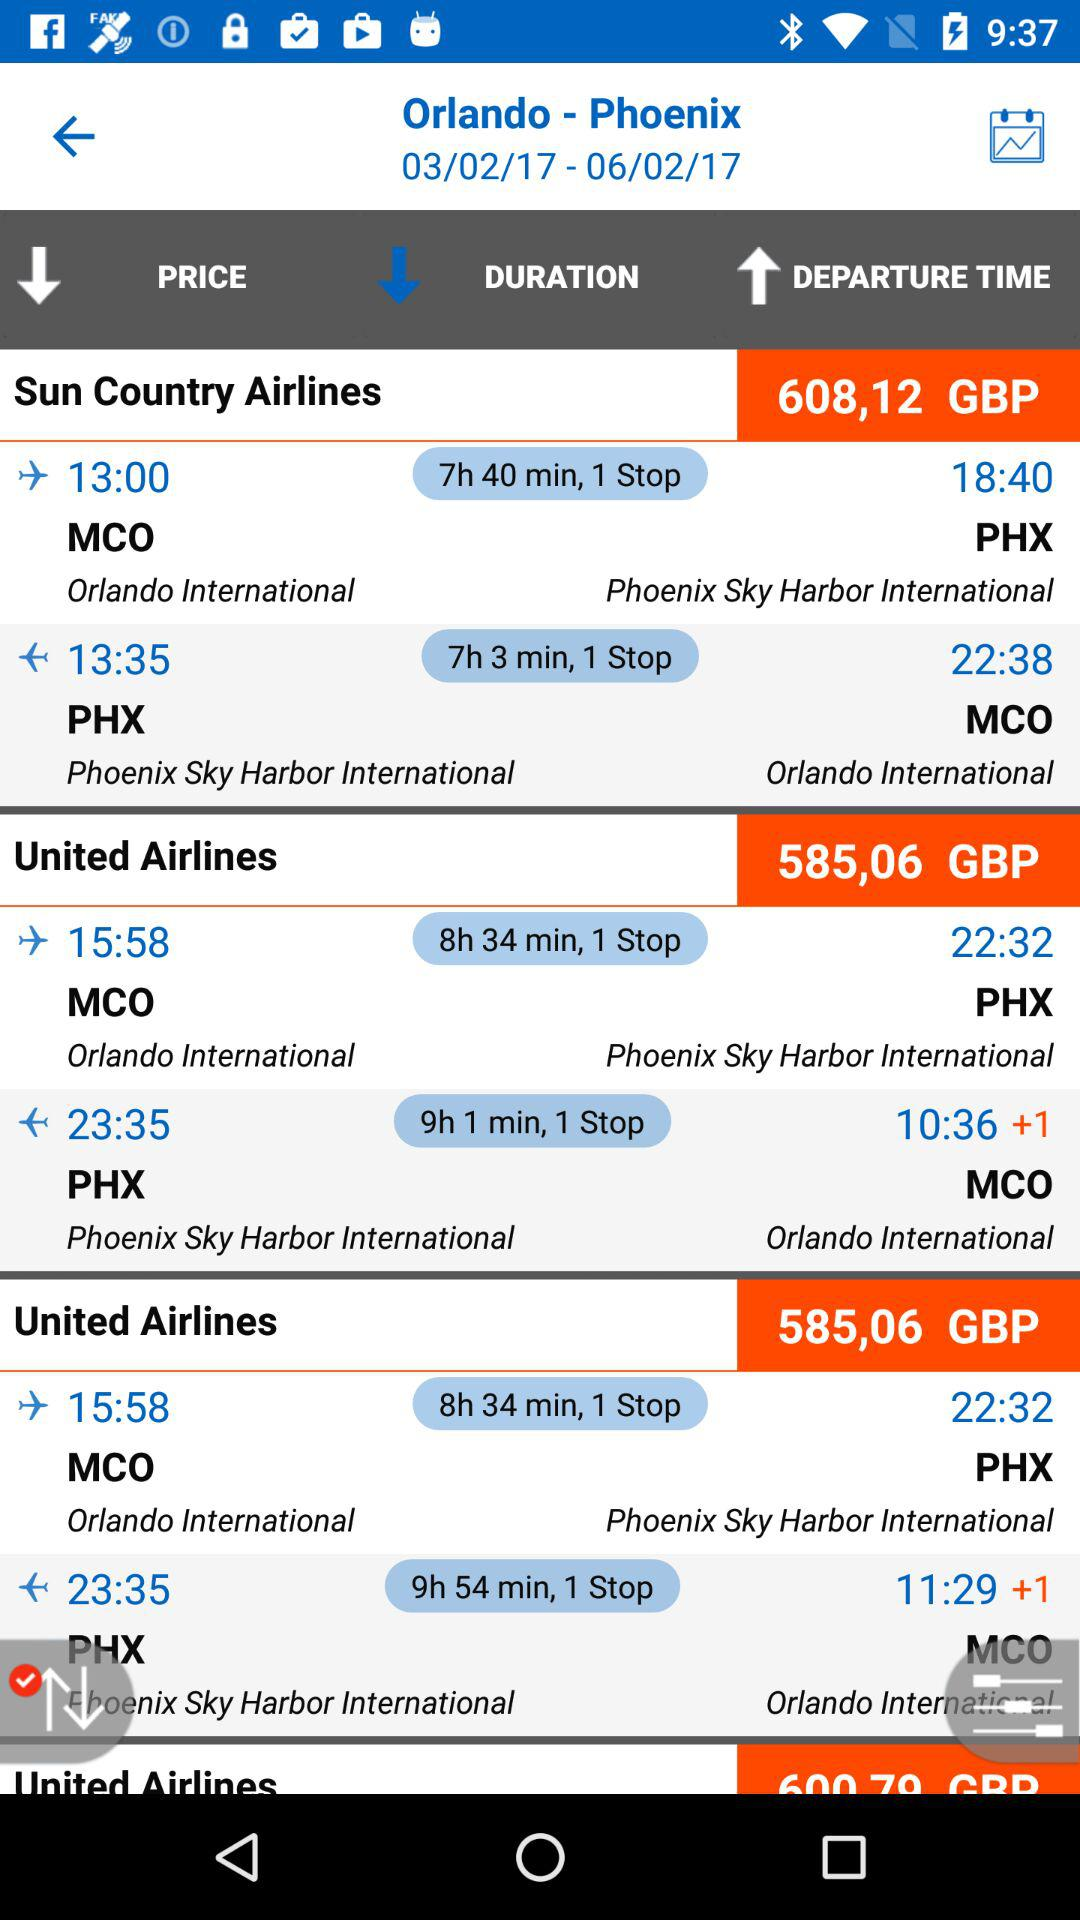What time is the flight from MCO to PHX? The flight time from MCO to PHX is 13:00. 